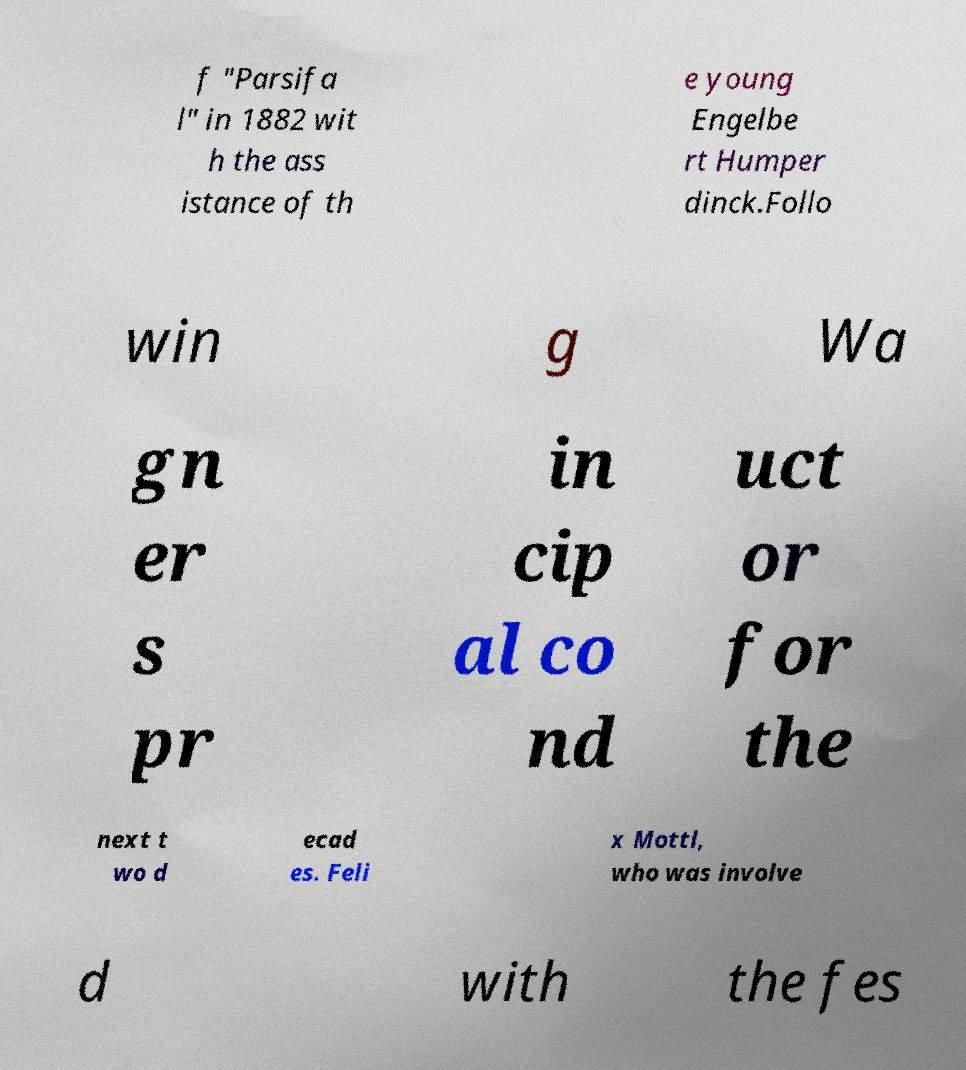Please read and relay the text visible in this image. What does it say? f "Parsifa l" in 1882 wit h the ass istance of th e young Engelbe rt Humper dinck.Follo win g Wa gn er s pr in cip al co nd uct or for the next t wo d ecad es. Feli x Mottl, who was involve d with the fes 